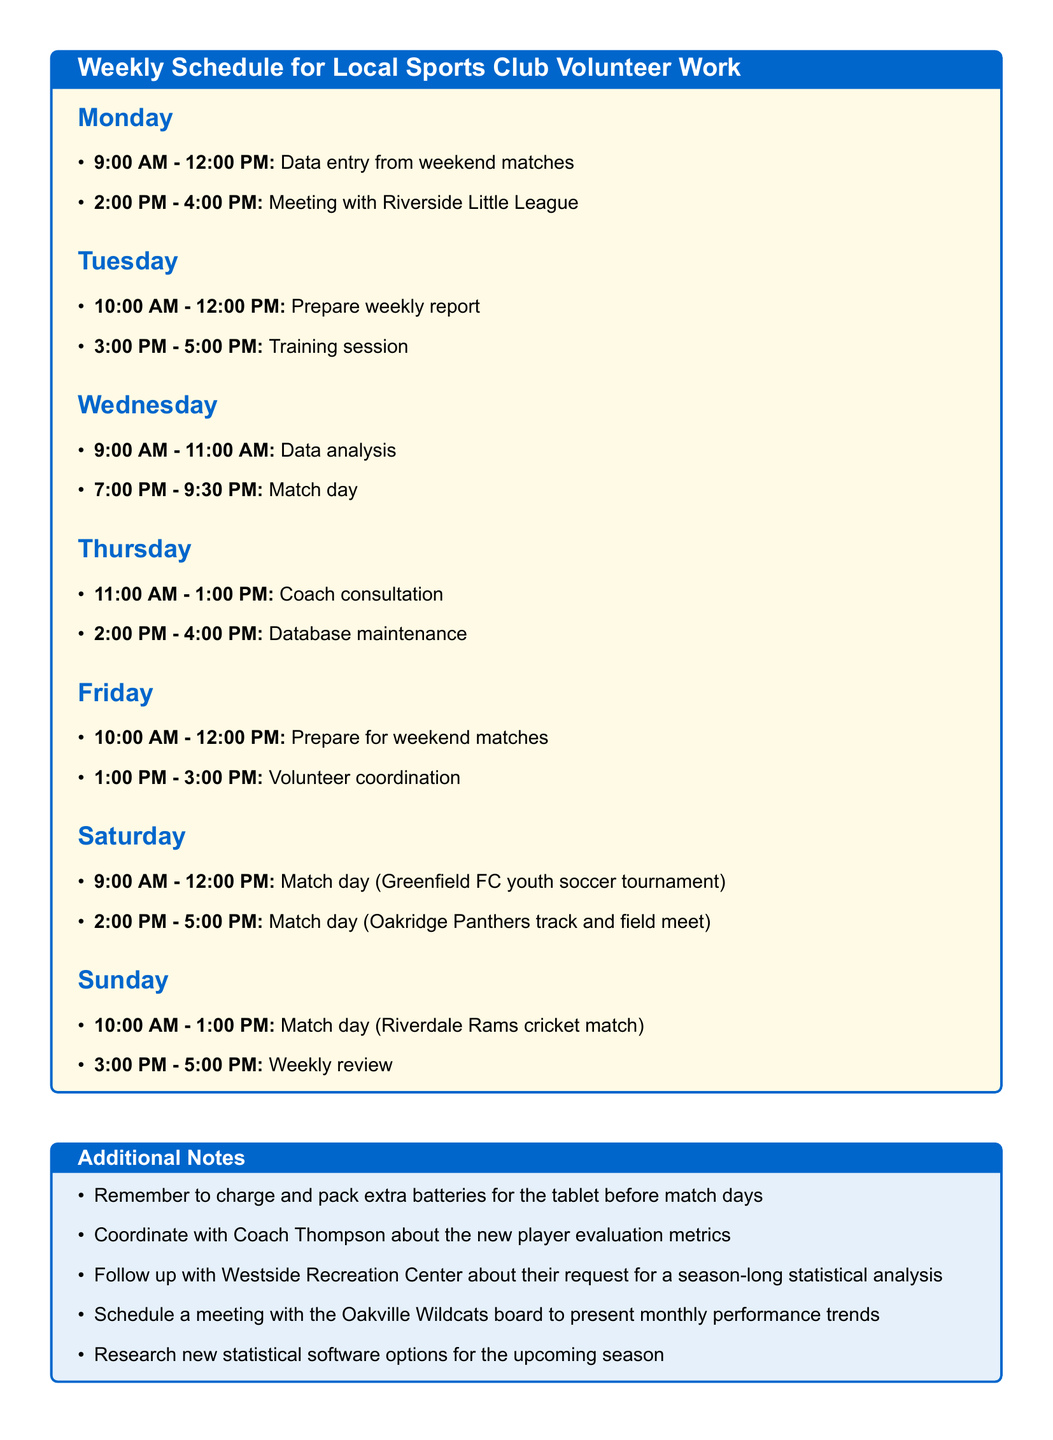What activities are scheduled for Monday? The activities listed for Monday are data entry from weekend matches and a meeting with Riverside Little League.
Answer: Data entry from weekend matches, meeting with Riverside Little League Which teams' match statistics are to be entered on Monday? The document specifies that match statistics for the Oakville Wildcats soccer team and the Pinegrove Ravens basketball team need to be entered.
Answer: Oakville Wildcats soccer team, Pinegrove Ravens basketball team What time does the match day for Hillside Hornets vs. Lakeview Titans start? The match day is scheduled to start at 7:00 PM on Wednesday.
Answer: 7:00 PM How many hours are allocated for volunteer coordination on Friday? Volunteer coordination on Friday is scheduled for 2 hours, from 1:00 PM to 3:00 PM.
Answer: 2 hours What task is planned for Sunday at 3:00 PM? The task scheduled for Sunday at 3:00 PM is a weekly review.
Answer: Weekly review Which day includes training for new volunteers? Training for new volunteers is scheduled on Tuesday.
Answer: Tuesday What is one of the additional notes related to match days? One of the additional notes is to charge and pack extra batteries for the tablet before match days.
Answer: Charge and pack extra batteries for the tablet Which sport is involved in the match day on Saturday at 2:00 PM? The match day at 2:00 PM on Saturday involves track and field.
Answer: Track and field What is the primary purpose of the meeting with Coach Rodriguez? The primary purpose of the meeting with Coach Rodriguez is to discuss player performance metrics.
Answer: Discuss player performance metrics 